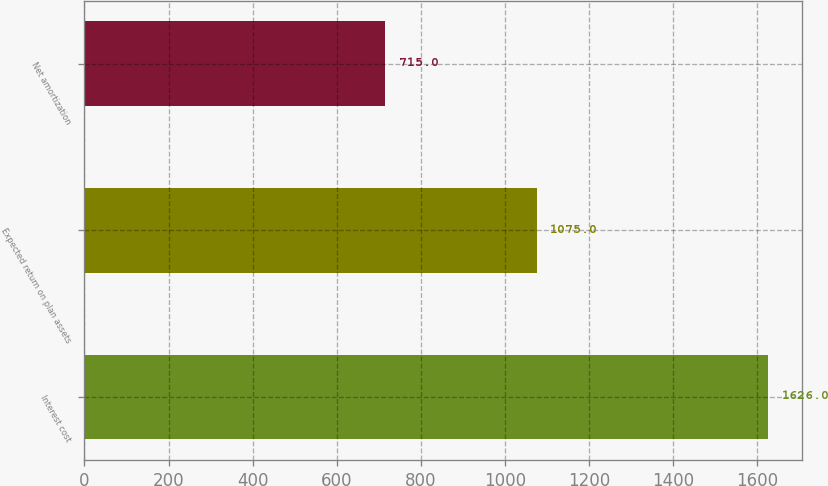Convert chart. <chart><loc_0><loc_0><loc_500><loc_500><bar_chart><fcel>Interest cost<fcel>Expected return on plan assets<fcel>Net amortization<nl><fcel>1626<fcel>1075<fcel>715<nl></chart> 